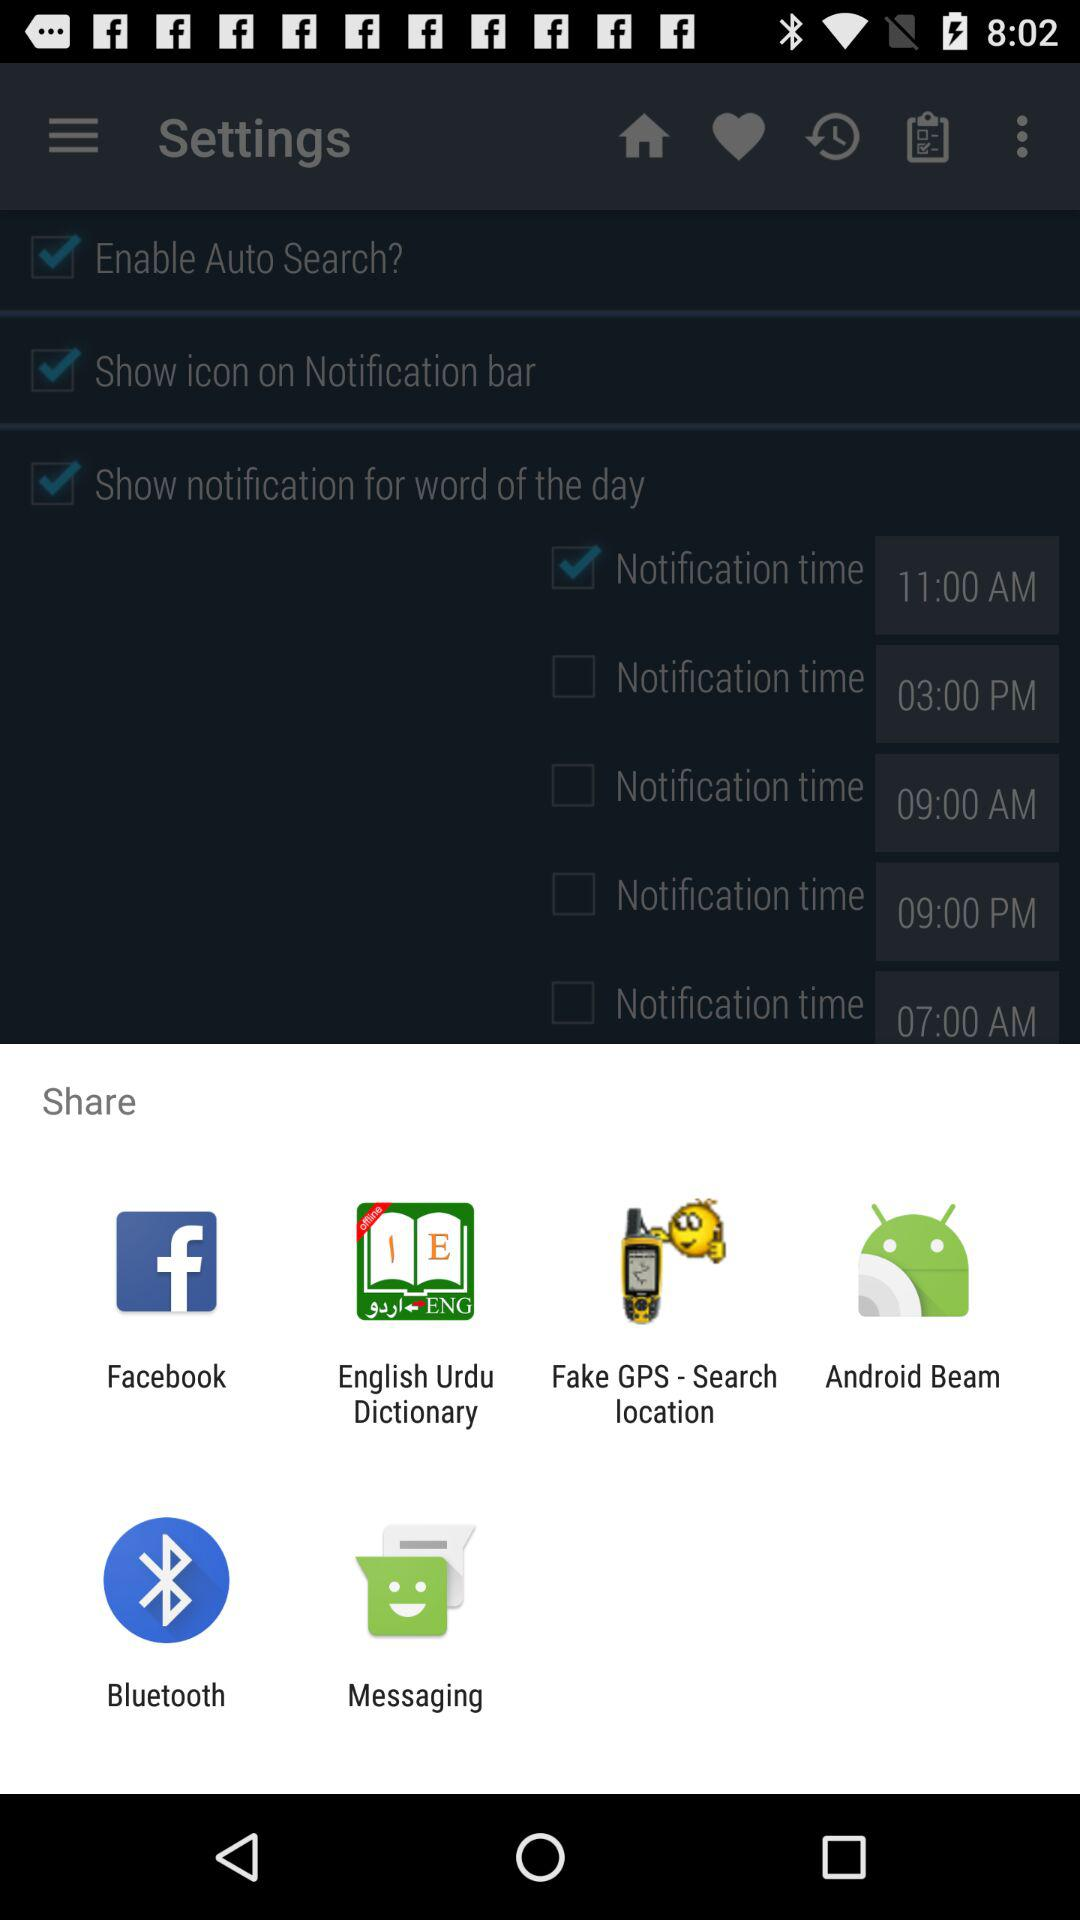Through which app can I share? You can share through "Facebook", "English Urdu Dictionary", "Fake GPS - Search location", "Android Beam", "Bluetooth" and "Messaging". 